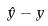<formula> <loc_0><loc_0><loc_500><loc_500>\hat { y } - y</formula> 